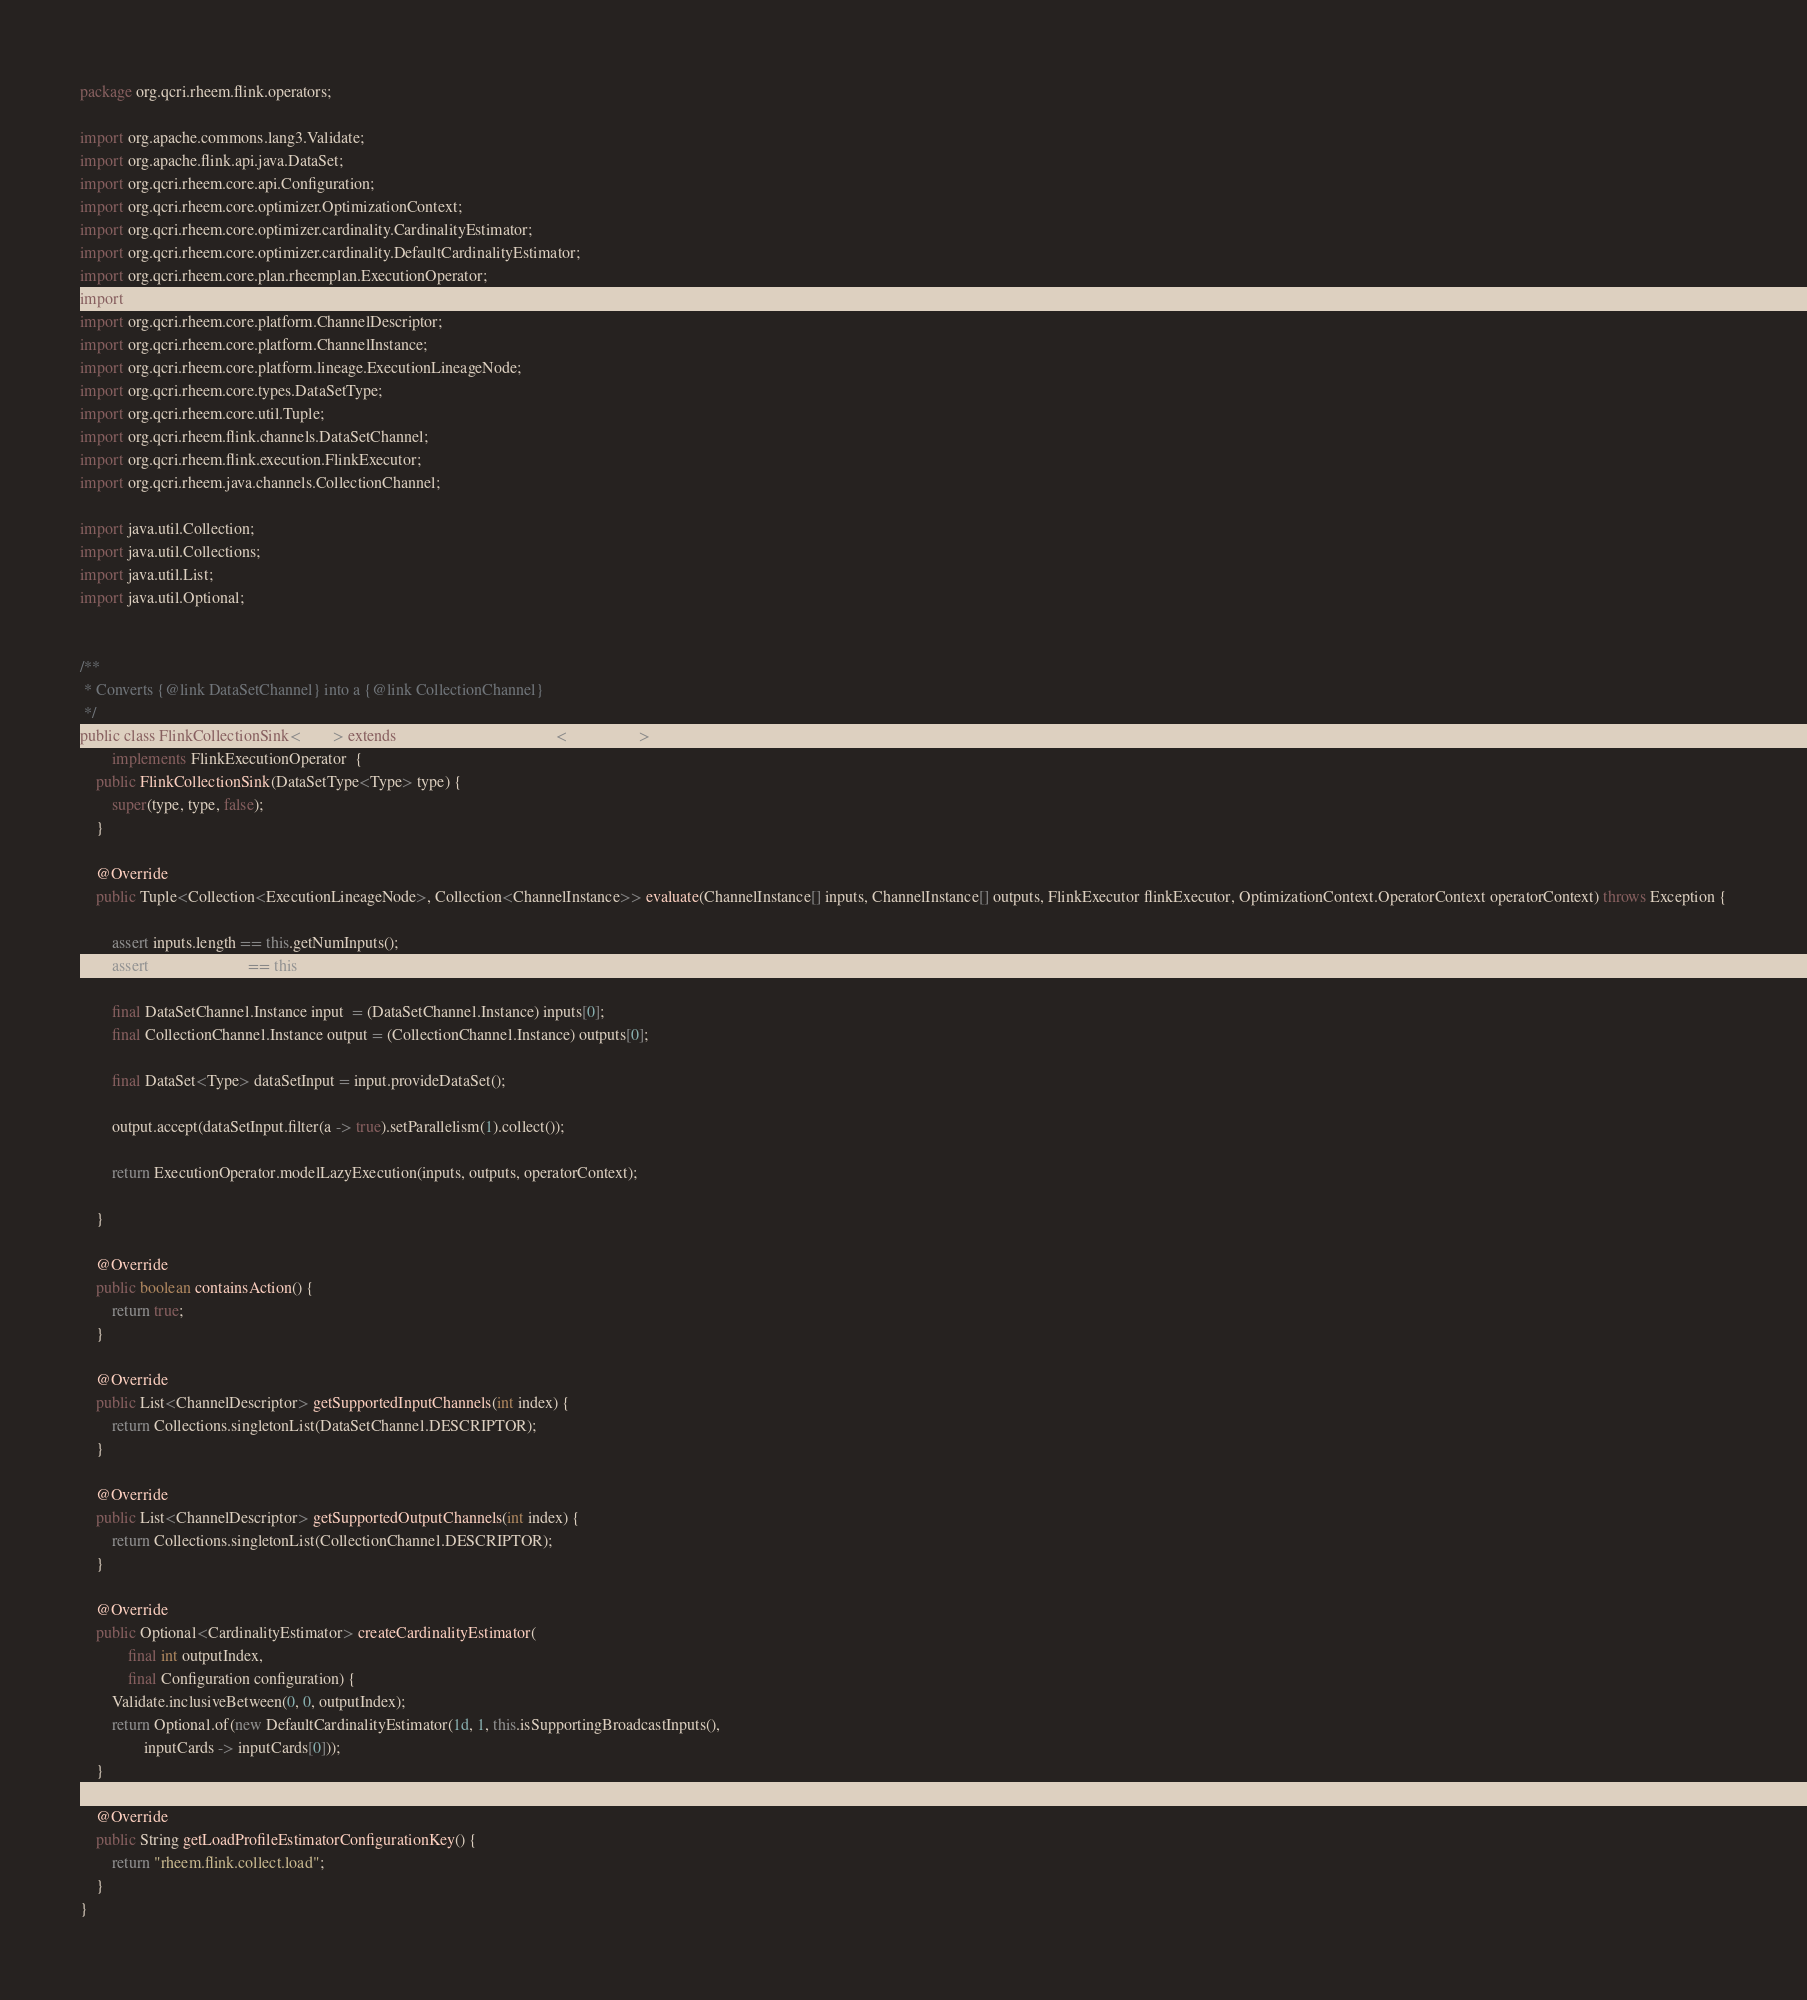<code> <loc_0><loc_0><loc_500><loc_500><_Java_>package org.qcri.rheem.flink.operators;

import org.apache.commons.lang3.Validate;
import org.apache.flink.api.java.DataSet;
import org.qcri.rheem.core.api.Configuration;
import org.qcri.rheem.core.optimizer.OptimizationContext;
import org.qcri.rheem.core.optimizer.cardinality.CardinalityEstimator;
import org.qcri.rheem.core.optimizer.cardinality.DefaultCardinalityEstimator;
import org.qcri.rheem.core.plan.rheemplan.ExecutionOperator;
import org.qcri.rheem.core.plan.rheemplan.UnaryToUnaryOperator;
import org.qcri.rheem.core.platform.ChannelDescriptor;
import org.qcri.rheem.core.platform.ChannelInstance;
import org.qcri.rheem.core.platform.lineage.ExecutionLineageNode;
import org.qcri.rheem.core.types.DataSetType;
import org.qcri.rheem.core.util.Tuple;
import org.qcri.rheem.flink.channels.DataSetChannel;
import org.qcri.rheem.flink.execution.FlinkExecutor;
import org.qcri.rheem.java.channels.CollectionChannel;

import java.util.Collection;
import java.util.Collections;
import java.util.List;
import java.util.Optional;


/**
 * Converts {@link DataSetChannel} into a {@link CollectionChannel}
 */
public class FlinkCollectionSink<Type> extends UnaryToUnaryOperator<Type, Type>
        implements FlinkExecutionOperator  {
    public FlinkCollectionSink(DataSetType<Type> type) {
        super(type, type, false);
    }

    @Override
    public Tuple<Collection<ExecutionLineageNode>, Collection<ChannelInstance>> evaluate(ChannelInstance[] inputs, ChannelInstance[] outputs, FlinkExecutor flinkExecutor, OptimizationContext.OperatorContext operatorContext) throws Exception {

        assert inputs.length == this.getNumInputs();
        assert outputs.length == this.getNumOutputs();

        final DataSetChannel.Instance input  = (DataSetChannel.Instance) inputs[0];
        final CollectionChannel.Instance output = (CollectionChannel.Instance) outputs[0];

        final DataSet<Type> dataSetInput = input.provideDataSet();

        output.accept(dataSetInput.filter(a -> true).setParallelism(1).collect());

        return ExecutionOperator.modelLazyExecution(inputs, outputs, operatorContext);

    }

    @Override
    public boolean containsAction() {
        return true;
    }

    @Override
    public List<ChannelDescriptor> getSupportedInputChannels(int index) {
        return Collections.singletonList(DataSetChannel.DESCRIPTOR);
    }

    @Override
    public List<ChannelDescriptor> getSupportedOutputChannels(int index) {
        return Collections.singletonList(CollectionChannel.DESCRIPTOR);
    }

    @Override
    public Optional<CardinalityEstimator> createCardinalityEstimator(
            final int outputIndex,
            final Configuration configuration) {
        Validate.inclusiveBetween(0, 0, outputIndex);
        return Optional.of(new DefaultCardinalityEstimator(1d, 1, this.isSupportingBroadcastInputs(),
                inputCards -> inputCards[0]));
    }

    @Override
    public String getLoadProfileEstimatorConfigurationKey() {
        return "rheem.flink.collect.load";
    }
}
</code> 